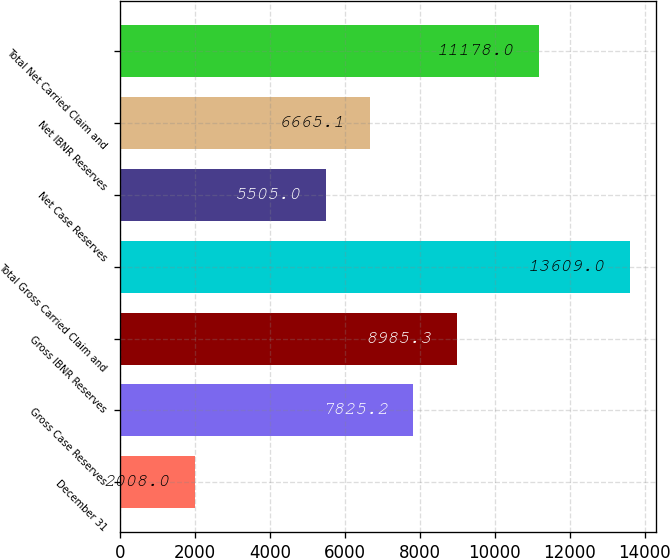<chart> <loc_0><loc_0><loc_500><loc_500><bar_chart><fcel>December 31<fcel>Gross Case Reserves<fcel>Gross IBNR Reserves<fcel>Total Gross Carried Claim and<fcel>Net Case Reserves<fcel>Net IBNR Reserves<fcel>Total Net Carried Claim and<nl><fcel>2008<fcel>7825.2<fcel>8985.3<fcel>13609<fcel>5505<fcel>6665.1<fcel>11178<nl></chart> 